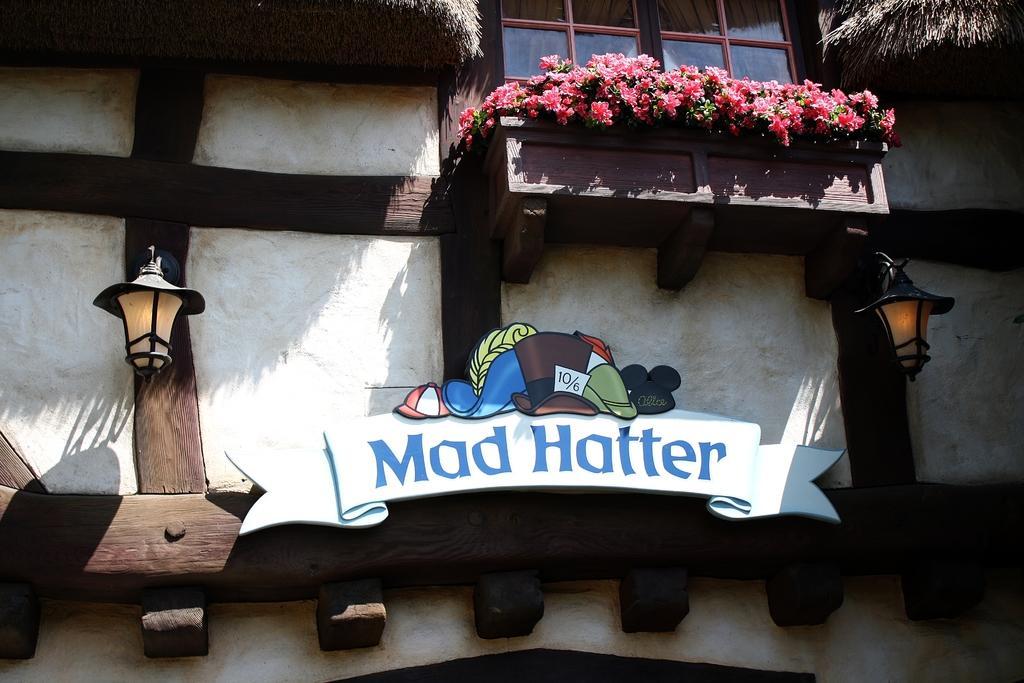Describe this image in one or two sentences. In the image we can see a building, on the building there are some lights and plants and flowers. 